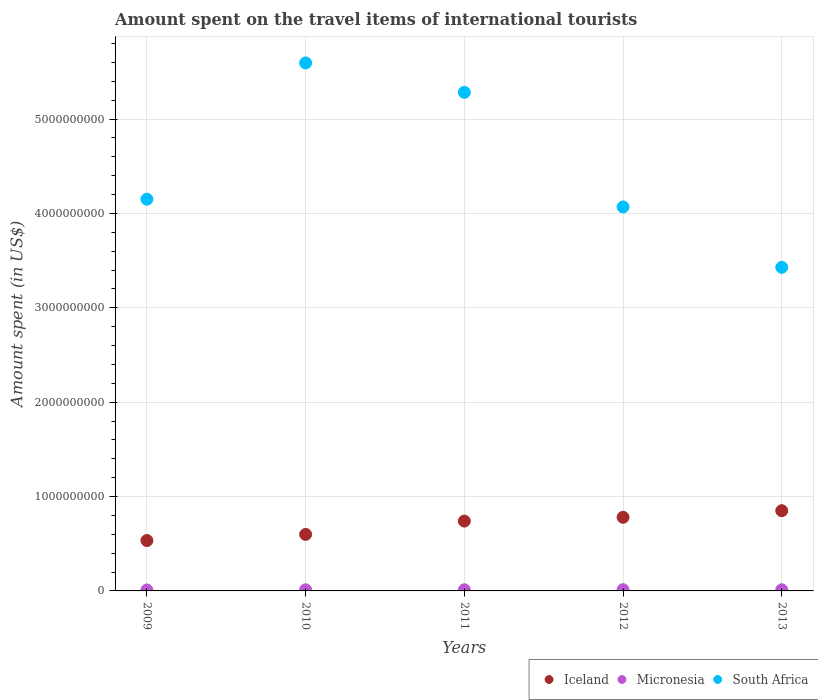Is the number of dotlines equal to the number of legend labels?
Give a very brief answer. Yes. What is the amount spent on the travel items of international tourists in Micronesia in 2009?
Your answer should be very brief. 1.00e+07. Across all years, what is the maximum amount spent on the travel items of international tourists in South Africa?
Provide a succinct answer. 5.60e+09. Across all years, what is the minimum amount spent on the travel items of international tourists in Iceland?
Give a very brief answer. 5.34e+08. In which year was the amount spent on the travel items of international tourists in Iceland maximum?
Ensure brevity in your answer.  2013. What is the total amount spent on the travel items of international tourists in Micronesia in the graph?
Offer a terse response. 5.90e+07. What is the difference between the amount spent on the travel items of international tourists in Iceland in 2009 and that in 2012?
Give a very brief answer. -2.46e+08. What is the difference between the amount spent on the travel items of international tourists in South Africa in 2011 and the amount spent on the travel items of international tourists in Iceland in 2010?
Provide a succinct answer. 4.68e+09. What is the average amount spent on the travel items of international tourists in Iceland per year?
Your answer should be compact. 7.01e+08. In the year 2013, what is the difference between the amount spent on the travel items of international tourists in South Africa and amount spent on the travel items of international tourists in Iceland?
Keep it short and to the point. 2.58e+09. What is the ratio of the amount spent on the travel items of international tourists in South Africa in 2012 to that in 2013?
Give a very brief answer. 1.19. Is the amount spent on the travel items of international tourists in Micronesia in 2011 less than that in 2013?
Make the answer very short. No. Is the difference between the amount spent on the travel items of international tourists in South Africa in 2009 and 2011 greater than the difference between the amount spent on the travel items of international tourists in Iceland in 2009 and 2011?
Ensure brevity in your answer.  No. What is the difference between the highest and the second highest amount spent on the travel items of international tourists in Micronesia?
Offer a terse response. 1.00e+06. What is the difference between the highest and the lowest amount spent on the travel items of international tourists in Iceland?
Provide a short and direct response. 3.16e+08. Does the amount spent on the travel items of international tourists in South Africa monotonically increase over the years?
Your answer should be very brief. No. How many dotlines are there?
Provide a short and direct response. 3. Does the graph contain any zero values?
Offer a very short reply. No. Where does the legend appear in the graph?
Keep it short and to the point. Bottom right. How many legend labels are there?
Keep it short and to the point. 3. What is the title of the graph?
Provide a short and direct response. Amount spent on the travel items of international tourists. What is the label or title of the X-axis?
Make the answer very short. Years. What is the label or title of the Y-axis?
Keep it short and to the point. Amount spent (in US$). What is the Amount spent (in US$) in Iceland in 2009?
Your response must be concise. 5.34e+08. What is the Amount spent (in US$) of Micronesia in 2009?
Your answer should be compact. 1.00e+07. What is the Amount spent (in US$) in South Africa in 2009?
Your response must be concise. 4.15e+09. What is the Amount spent (in US$) of Iceland in 2010?
Your response must be concise. 5.99e+08. What is the Amount spent (in US$) in Micronesia in 2010?
Your answer should be compact. 1.20e+07. What is the Amount spent (in US$) in South Africa in 2010?
Offer a very short reply. 5.60e+09. What is the Amount spent (in US$) of Iceland in 2011?
Provide a succinct answer. 7.40e+08. What is the Amount spent (in US$) in Micronesia in 2011?
Your response must be concise. 1.20e+07. What is the Amount spent (in US$) of South Africa in 2011?
Your response must be concise. 5.28e+09. What is the Amount spent (in US$) in Iceland in 2012?
Provide a short and direct response. 7.80e+08. What is the Amount spent (in US$) in Micronesia in 2012?
Your answer should be very brief. 1.30e+07. What is the Amount spent (in US$) in South Africa in 2012?
Ensure brevity in your answer.  4.07e+09. What is the Amount spent (in US$) in Iceland in 2013?
Provide a short and direct response. 8.50e+08. What is the Amount spent (in US$) in South Africa in 2013?
Your response must be concise. 3.43e+09. Across all years, what is the maximum Amount spent (in US$) of Iceland?
Offer a very short reply. 8.50e+08. Across all years, what is the maximum Amount spent (in US$) in Micronesia?
Make the answer very short. 1.30e+07. Across all years, what is the maximum Amount spent (in US$) of South Africa?
Your answer should be compact. 5.60e+09. Across all years, what is the minimum Amount spent (in US$) in Iceland?
Your answer should be compact. 5.34e+08. Across all years, what is the minimum Amount spent (in US$) of South Africa?
Keep it short and to the point. 3.43e+09. What is the total Amount spent (in US$) in Iceland in the graph?
Ensure brevity in your answer.  3.50e+09. What is the total Amount spent (in US$) in Micronesia in the graph?
Make the answer very short. 5.90e+07. What is the total Amount spent (in US$) of South Africa in the graph?
Ensure brevity in your answer.  2.25e+1. What is the difference between the Amount spent (in US$) of Iceland in 2009 and that in 2010?
Offer a very short reply. -6.50e+07. What is the difference between the Amount spent (in US$) of South Africa in 2009 and that in 2010?
Your answer should be compact. -1.44e+09. What is the difference between the Amount spent (in US$) in Iceland in 2009 and that in 2011?
Give a very brief answer. -2.06e+08. What is the difference between the Amount spent (in US$) of Micronesia in 2009 and that in 2011?
Your answer should be compact. -2.00e+06. What is the difference between the Amount spent (in US$) of South Africa in 2009 and that in 2011?
Your answer should be compact. -1.13e+09. What is the difference between the Amount spent (in US$) in Iceland in 2009 and that in 2012?
Your answer should be very brief. -2.46e+08. What is the difference between the Amount spent (in US$) of Micronesia in 2009 and that in 2012?
Give a very brief answer. -3.00e+06. What is the difference between the Amount spent (in US$) of South Africa in 2009 and that in 2012?
Offer a very short reply. 8.20e+07. What is the difference between the Amount spent (in US$) in Iceland in 2009 and that in 2013?
Provide a succinct answer. -3.16e+08. What is the difference between the Amount spent (in US$) of Micronesia in 2009 and that in 2013?
Give a very brief answer. -2.00e+06. What is the difference between the Amount spent (in US$) in South Africa in 2009 and that in 2013?
Keep it short and to the point. 7.22e+08. What is the difference between the Amount spent (in US$) in Iceland in 2010 and that in 2011?
Your response must be concise. -1.41e+08. What is the difference between the Amount spent (in US$) of South Africa in 2010 and that in 2011?
Offer a terse response. 3.12e+08. What is the difference between the Amount spent (in US$) of Iceland in 2010 and that in 2012?
Provide a short and direct response. -1.81e+08. What is the difference between the Amount spent (in US$) in Micronesia in 2010 and that in 2012?
Your response must be concise. -1.00e+06. What is the difference between the Amount spent (in US$) of South Africa in 2010 and that in 2012?
Ensure brevity in your answer.  1.53e+09. What is the difference between the Amount spent (in US$) in Iceland in 2010 and that in 2013?
Provide a short and direct response. -2.51e+08. What is the difference between the Amount spent (in US$) of South Africa in 2010 and that in 2013?
Ensure brevity in your answer.  2.17e+09. What is the difference between the Amount spent (in US$) of Iceland in 2011 and that in 2012?
Provide a short and direct response. -4.00e+07. What is the difference between the Amount spent (in US$) in Micronesia in 2011 and that in 2012?
Provide a succinct answer. -1.00e+06. What is the difference between the Amount spent (in US$) in South Africa in 2011 and that in 2012?
Keep it short and to the point. 1.21e+09. What is the difference between the Amount spent (in US$) in Iceland in 2011 and that in 2013?
Provide a short and direct response. -1.10e+08. What is the difference between the Amount spent (in US$) in Micronesia in 2011 and that in 2013?
Ensure brevity in your answer.  0. What is the difference between the Amount spent (in US$) of South Africa in 2011 and that in 2013?
Ensure brevity in your answer.  1.85e+09. What is the difference between the Amount spent (in US$) in Iceland in 2012 and that in 2013?
Keep it short and to the point. -7.00e+07. What is the difference between the Amount spent (in US$) of Micronesia in 2012 and that in 2013?
Ensure brevity in your answer.  1.00e+06. What is the difference between the Amount spent (in US$) in South Africa in 2012 and that in 2013?
Provide a succinct answer. 6.40e+08. What is the difference between the Amount spent (in US$) of Iceland in 2009 and the Amount spent (in US$) of Micronesia in 2010?
Keep it short and to the point. 5.22e+08. What is the difference between the Amount spent (in US$) in Iceland in 2009 and the Amount spent (in US$) in South Africa in 2010?
Offer a terse response. -5.06e+09. What is the difference between the Amount spent (in US$) of Micronesia in 2009 and the Amount spent (in US$) of South Africa in 2010?
Provide a short and direct response. -5.58e+09. What is the difference between the Amount spent (in US$) of Iceland in 2009 and the Amount spent (in US$) of Micronesia in 2011?
Give a very brief answer. 5.22e+08. What is the difference between the Amount spent (in US$) of Iceland in 2009 and the Amount spent (in US$) of South Africa in 2011?
Ensure brevity in your answer.  -4.75e+09. What is the difference between the Amount spent (in US$) of Micronesia in 2009 and the Amount spent (in US$) of South Africa in 2011?
Your response must be concise. -5.27e+09. What is the difference between the Amount spent (in US$) of Iceland in 2009 and the Amount spent (in US$) of Micronesia in 2012?
Provide a short and direct response. 5.21e+08. What is the difference between the Amount spent (in US$) in Iceland in 2009 and the Amount spent (in US$) in South Africa in 2012?
Your answer should be compact. -3.54e+09. What is the difference between the Amount spent (in US$) in Micronesia in 2009 and the Amount spent (in US$) in South Africa in 2012?
Your answer should be compact. -4.06e+09. What is the difference between the Amount spent (in US$) of Iceland in 2009 and the Amount spent (in US$) of Micronesia in 2013?
Offer a very short reply. 5.22e+08. What is the difference between the Amount spent (in US$) in Iceland in 2009 and the Amount spent (in US$) in South Africa in 2013?
Your response must be concise. -2.90e+09. What is the difference between the Amount spent (in US$) in Micronesia in 2009 and the Amount spent (in US$) in South Africa in 2013?
Offer a very short reply. -3.42e+09. What is the difference between the Amount spent (in US$) in Iceland in 2010 and the Amount spent (in US$) in Micronesia in 2011?
Ensure brevity in your answer.  5.87e+08. What is the difference between the Amount spent (in US$) of Iceland in 2010 and the Amount spent (in US$) of South Africa in 2011?
Offer a very short reply. -4.68e+09. What is the difference between the Amount spent (in US$) in Micronesia in 2010 and the Amount spent (in US$) in South Africa in 2011?
Your answer should be compact. -5.27e+09. What is the difference between the Amount spent (in US$) in Iceland in 2010 and the Amount spent (in US$) in Micronesia in 2012?
Provide a succinct answer. 5.86e+08. What is the difference between the Amount spent (in US$) of Iceland in 2010 and the Amount spent (in US$) of South Africa in 2012?
Your answer should be very brief. -3.47e+09. What is the difference between the Amount spent (in US$) of Micronesia in 2010 and the Amount spent (in US$) of South Africa in 2012?
Make the answer very short. -4.06e+09. What is the difference between the Amount spent (in US$) of Iceland in 2010 and the Amount spent (in US$) of Micronesia in 2013?
Your response must be concise. 5.87e+08. What is the difference between the Amount spent (in US$) of Iceland in 2010 and the Amount spent (in US$) of South Africa in 2013?
Your answer should be very brief. -2.83e+09. What is the difference between the Amount spent (in US$) in Micronesia in 2010 and the Amount spent (in US$) in South Africa in 2013?
Give a very brief answer. -3.42e+09. What is the difference between the Amount spent (in US$) of Iceland in 2011 and the Amount spent (in US$) of Micronesia in 2012?
Offer a terse response. 7.27e+08. What is the difference between the Amount spent (in US$) of Iceland in 2011 and the Amount spent (in US$) of South Africa in 2012?
Keep it short and to the point. -3.33e+09. What is the difference between the Amount spent (in US$) in Micronesia in 2011 and the Amount spent (in US$) in South Africa in 2012?
Your answer should be compact. -4.06e+09. What is the difference between the Amount spent (in US$) in Iceland in 2011 and the Amount spent (in US$) in Micronesia in 2013?
Give a very brief answer. 7.28e+08. What is the difference between the Amount spent (in US$) in Iceland in 2011 and the Amount spent (in US$) in South Africa in 2013?
Your answer should be very brief. -2.69e+09. What is the difference between the Amount spent (in US$) in Micronesia in 2011 and the Amount spent (in US$) in South Africa in 2013?
Your response must be concise. -3.42e+09. What is the difference between the Amount spent (in US$) in Iceland in 2012 and the Amount spent (in US$) in Micronesia in 2013?
Give a very brief answer. 7.68e+08. What is the difference between the Amount spent (in US$) in Iceland in 2012 and the Amount spent (in US$) in South Africa in 2013?
Make the answer very short. -2.65e+09. What is the difference between the Amount spent (in US$) of Micronesia in 2012 and the Amount spent (in US$) of South Africa in 2013?
Ensure brevity in your answer.  -3.42e+09. What is the average Amount spent (in US$) in Iceland per year?
Your response must be concise. 7.01e+08. What is the average Amount spent (in US$) of Micronesia per year?
Your response must be concise. 1.18e+07. What is the average Amount spent (in US$) in South Africa per year?
Keep it short and to the point. 4.51e+09. In the year 2009, what is the difference between the Amount spent (in US$) of Iceland and Amount spent (in US$) of Micronesia?
Give a very brief answer. 5.24e+08. In the year 2009, what is the difference between the Amount spent (in US$) of Iceland and Amount spent (in US$) of South Africa?
Your response must be concise. -3.62e+09. In the year 2009, what is the difference between the Amount spent (in US$) in Micronesia and Amount spent (in US$) in South Africa?
Provide a short and direct response. -4.14e+09. In the year 2010, what is the difference between the Amount spent (in US$) of Iceland and Amount spent (in US$) of Micronesia?
Give a very brief answer. 5.87e+08. In the year 2010, what is the difference between the Amount spent (in US$) in Iceland and Amount spent (in US$) in South Africa?
Provide a short and direct response. -5.00e+09. In the year 2010, what is the difference between the Amount spent (in US$) of Micronesia and Amount spent (in US$) of South Africa?
Ensure brevity in your answer.  -5.58e+09. In the year 2011, what is the difference between the Amount spent (in US$) of Iceland and Amount spent (in US$) of Micronesia?
Give a very brief answer. 7.28e+08. In the year 2011, what is the difference between the Amount spent (in US$) of Iceland and Amount spent (in US$) of South Africa?
Give a very brief answer. -4.54e+09. In the year 2011, what is the difference between the Amount spent (in US$) of Micronesia and Amount spent (in US$) of South Africa?
Your answer should be compact. -5.27e+09. In the year 2012, what is the difference between the Amount spent (in US$) in Iceland and Amount spent (in US$) in Micronesia?
Provide a short and direct response. 7.67e+08. In the year 2012, what is the difference between the Amount spent (in US$) in Iceland and Amount spent (in US$) in South Africa?
Make the answer very short. -3.29e+09. In the year 2012, what is the difference between the Amount spent (in US$) in Micronesia and Amount spent (in US$) in South Africa?
Keep it short and to the point. -4.06e+09. In the year 2013, what is the difference between the Amount spent (in US$) of Iceland and Amount spent (in US$) of Micronesia?
Give a very brief answer. 8.38e+08. In the year 2013, what is the difference between the Amount spent (in US$) in Iceland and Amount spent (in US$) in South Africa?
Your answer should be compact. -2.58e+09. In the year 2013, what is the difference between the Amount spent (in US$) in Micronesia and Amount spent (in US$) in South Africa?
Keep it short and to the point. -3.42e+09. What is the ratio of the Amount spent (in US$) in Iceland in 2009 to that in 2010?
Your answer should be very brief. 0.89. What is the ratio of the Amount spent (in US$) of South Africa in 2009 to that in 2010?
Provide a short and direct response. 0.74. What is the ratio of the Amount spent (in US$) of Iceland in 2009 to that in 2011?
Your response must be concise. 0.72. What is the ratio of the Amount spent (in US$) in Micronesia in 2009 to that in 2011?
Offer a very short reply. 0.83. What is the ratio of the Amount spent (in US$) in South Africa in 2009 to that in 2011?
Make the answer very short. 0.79. What is the ratio of the Amount spent (in US$) of Iceland in 2009 to that in 2012?
Your response must be concise. 0.68. What is the ratio of the Amount spent (in US$) of Micronesia in 2009 to that in 2012?
Your answer should be compact. 0.77. What is the ratio of the Amount spent (in US$) in South Africa in 2009 to that in 2012?
Your answer should be very brief. 1.02. What is the ratio of the Amount spent (in US$) in Iceland in 2009 to that in 2013?
Provide a short and direct response. 0.63. What is the ratio of the Amount spent (in US$) of Micronesia in 2009 to that in 2013?
Your answer should be very brief. 0.83. What is the ratio of the Amount spent (in US$) in South Africa in 2009 to that in 2013?
Your answer should be compact. 1.21. What is the ratio of the Amount spent (in US$) in Iceland in 2010 to that in 2011?
Offer a terse response. 0.81. What is the ratio of the Amount spent (in US$) in Micronesia in 2010 to that in 2011?
Your response must be concise. 1. What is the ratio of the Amount spent (in US$) in South Africa in 2010 to that in 2011?
Ensure brevity in your answer.  1.06. What is the ratio of the Amount spent (in US$) of Iceland in 2010 to that in 2012?
Provide a succinct answer. 0.77. What is the ratio of the Amount spent (in US$) of Micronesia in 2010 to that in 2012?
Your answer should be compact. 0.92. What is the ratio of the Amount spent (in US$) in South Africa in 2010 to that in 2012?
Your response must be concise. 1.38. What is the ratio of the Amount spent (in US$) of Iceland in 2010 to that in 2013?
Keep it short and to the point. 0.7. What is the ratio of the Amount spent (in US$) in Micronesia in 2010 to that in 2013?
Your answer should be very brief. 1. What is the ratio of the Amount spent (in US$) of South Africa in 2010 to that in 2013?
Provide a short and direct response. 1.63. What is the ratio of the Amount spent (in US$) of Iceland in 2011 to that in 2012?
Offer a terse response. 0.95. What is the ratio of the Amount spent (in US$) in South Africa in 2011 to that in 2012?
Offer a very short reply. 1.3. What is the ratio of the Amount spent (in US$) in Iceland in 2011 to that in 2013?
Provide a succinct answer. 0.87. What is the ratio of the Amount spent (in US$) in South Africa in 2011 to that in 2013?
Your answer should be very brief. 1.54. What is the ratio of the Amount spent (in US$) in Iceland in 2012 to that in 2013?
Provide a succinct answer. 0.92. What is the ratio of the Amount spent (in US$) of South Africa in 2012 to that in 2013?
Offer a terse response. 1.19. What is the difference between the highest and the second highest Amount spent (in US$) of Iceland?
Provide a succinct answer. 7.00e+07. What is the difference between the highest and the second highest Amount spent (in US$) in South Africa?
Provide a succinct answer. 3.12e+08. What is the difference between the highest and the lowest Amount spent (in US$) of Iceland?
Your answer should be compact. 3.16e+08. What is the difference between the highest and the lowest Amount spent (in US$) in Micronesia?
Your answer should be very brief. 3.00e+06. What is the difference between the highest and the lowest Amount spent (in US$) of South Africa?
Offer a terse response. 2.17e+09. 